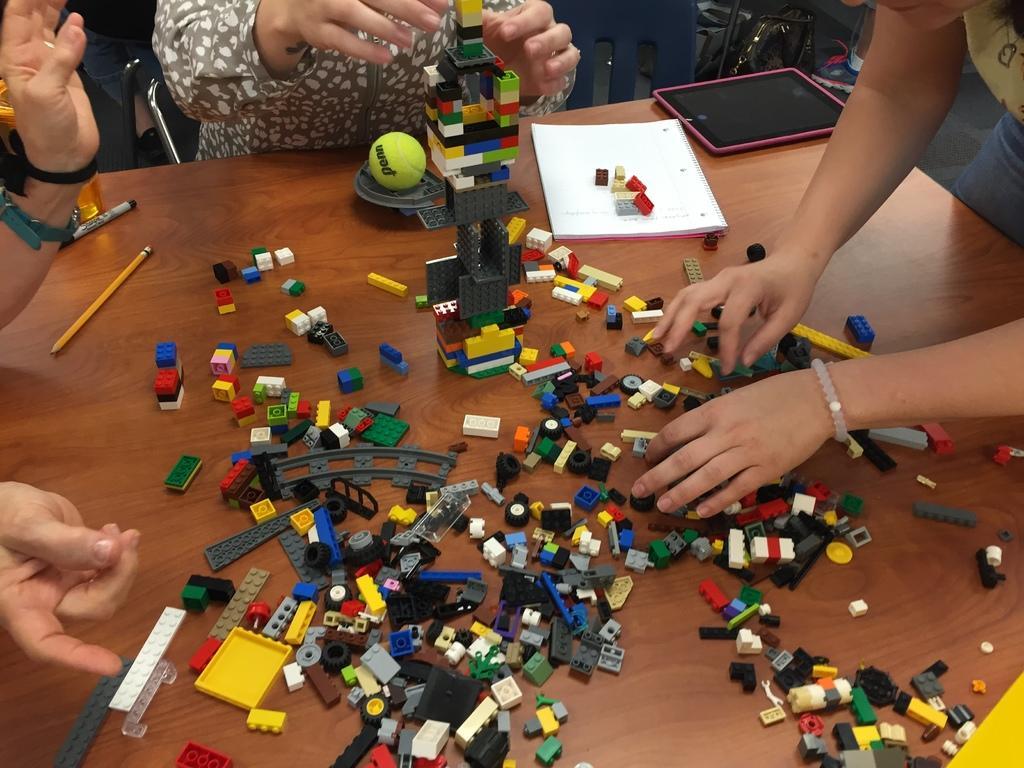In one or two sentences, can you explain what this image depicts? In this image there are some plastic construction toys are kept on a table as we can see in middle of this image ,and there is one person is at left side of this image and one more is at right side of this image and one is at top of this image. There is one yellow color ball is kept on the table at top of this image ,and there is a white color book at right side to this image , and there is a mobile is at right side to this book, and there is a chair at top of this image. 